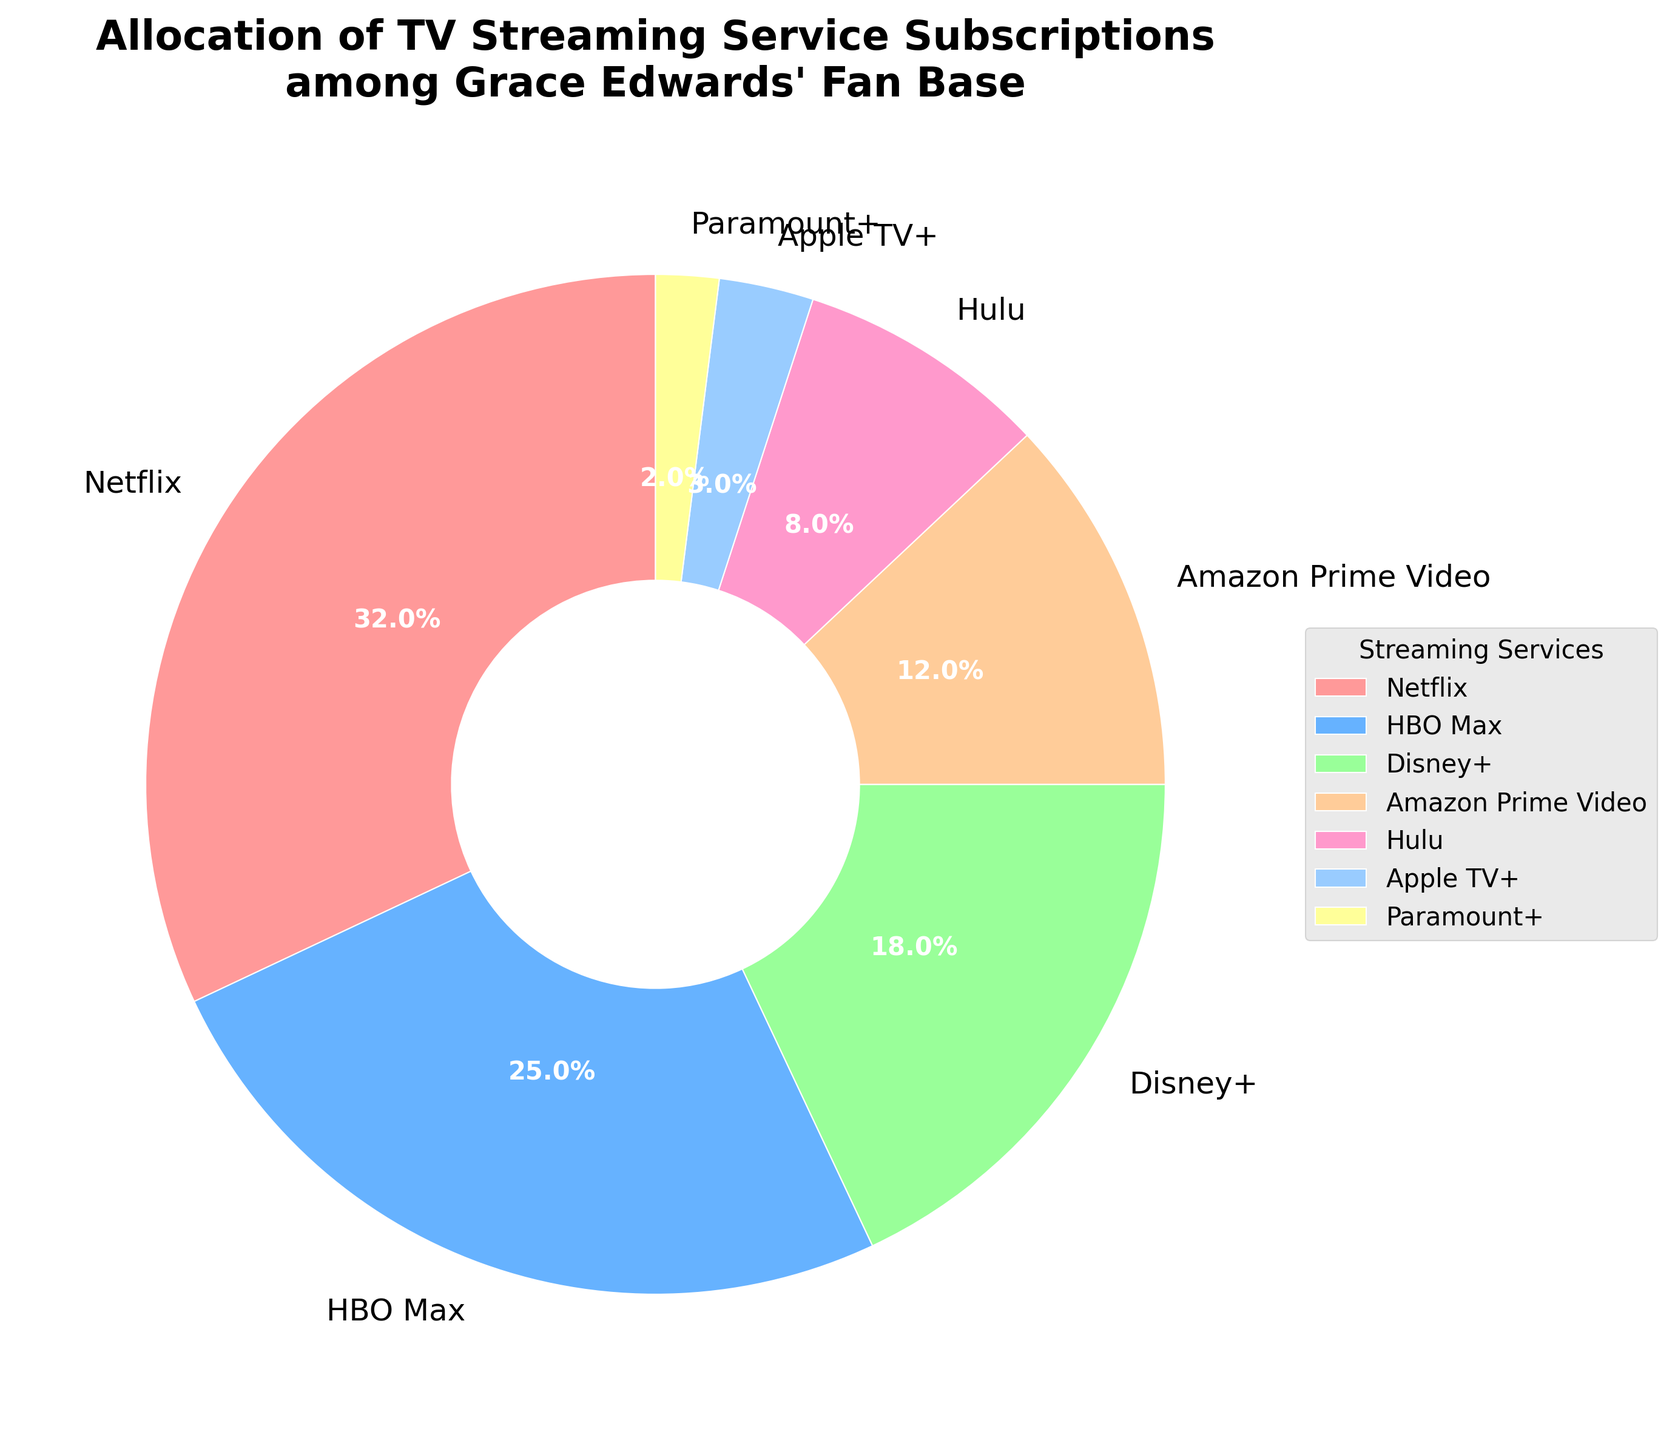Which streaming service has the highest percentage of subscriptions among Grace Edwards' fan base? According to the chart, the streaming service with the highest percentage of subscriptions is the largest wedge in the pie chart.
Answer: Netflix What is the combined percentage of subscriptions for Disney+ and Amazon Prime Video? To find the combined percentage, add the Disney+ percentage (18%) with the Amazon Prime Video percentage (12%). The sum is 18% + 12% = 30%.
Answer: 30% Which streaming service has a higher subscription percentage, Hulu or Apple TV+? By comparing the wedges labeled Hulu and Apple TV+ in the pie chart, Hulu's percentage (8%) is higher than Apple TV+'s percentage (3%).
Answer: Hulu By how much does HBO Max's subscription percentage exceed Hulu's? Subtract Hulu's percentage (8%) from HBO Max's percentage (25%). The difference is 25% - 8% = 17%.
Answer: 17% What is the total percentage of subscriptions for streaming services with a percentage lower than 10%? Apple TV+ (3%), Paramount+ (2%), and Hulu (8%) are all below 10%. The total is 3% + 2% + 8% = 13%.
Answer: 13% Which wedge is colored red? The pie chart's largest wedge corresponds to the largest percentage, which is for Netflix. According to the color scheme, Netflix is colored red.
Answer: Netflix If the percentages of Netflix and Disney+ were swapped, what would the new percentage for Netflix be? If Netflix's percentage (32%) and Disney+'s percentage (18%) were swapped, Netflix would then be 18%.
Answer: 18% Which service has the smallest wedge in the pie chart? The smallest wedge on the pie chart corresponds to the smallest percentage, which is for Paramount+ (2%).
Answer: Paramount+ If 5% more fans subscribed to Amazon Prime Video, what would the new percentage be? Adding 5% to Amazon Prime Video's current percentage (12%) gives a new percentage of 12% + 5% = 17%.
Answer: 17% What is the ratio of the percentage subscribers for HBO Max to Apple TV+? To find the ratio, divide HBO Max's percentage (25%) by Apple TV+'s percentage (3%). The ratio is 25 / 3 ≈ 8.33.
Answer: 8.33 